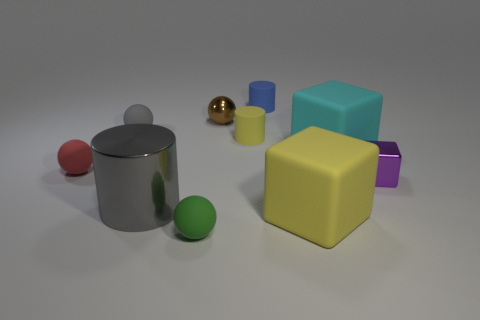How many rubber objects are cubes or small spheres?
Your response must be concise. 5. The large object to the left of the small blue thing is what color?
Give a very brief answer. Gray. There is another shiny thing that is the same size as the cyan thing; what shape is it?
Your answer should be compact. Cylinder. Does the tiny shiny ball have the same color as the matte cube behind the large yellow block?
Offer a very short reply. No. What number of objects are either things behind the tiny green object or cyan matte blocks on the left side of the metallic block?
Keep it short and to the point. 9. What material is the brown ball that is the same size as the purple metallic block?
Provide a succinct answer. Metal. What number of other objects are the same material as the small gray sphere?
Ensure brevity in your answer.  6. Is the shape of the matte object that is behind the brown sphere the same as the yellow thing behind the purple metal cube?
Provide a succinct answer. Yes. What is the color of the rubber ball that is in front of the gray thing that is in front of the tiny yellow rubber cylinder right of the metal cylinder?
Provide a succinct answer. Green. What number of other objects are the same color as the metal cylinder?
Provide a succinct answer. 1. 